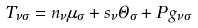<formula> <loc_0><loc_0><loc_500><loc_500>T _ { \nu \sigma } = n _ { \nu } \mu _ { \sigma } + s _ { \nu } \Theta _ { \sigma } + P \, g _ { \nu \sigma }</formula> 